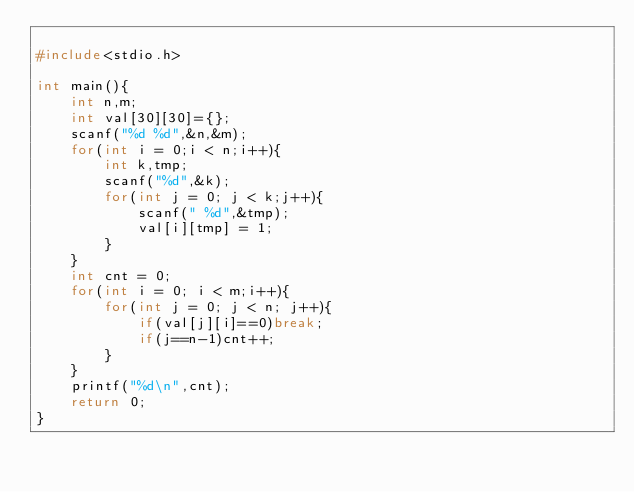<code> <loc_0><loc_0><loc_500><loc_500><_C_>
#include<stdio.h>

int main(){
	int n,m;
	int val[30][30]={};
	scanf("%d %d",&n,&m);
	for(int i = 0;i < n;i++){
		int k,tmp;
		scanf("%d",&k);
		for(int j = 0; j < k;j++){
			scanf(" %d",&tmp);
			val[i][tmp] = 1;
		}
	}
	int cnt = 0;
	for(int i = 0; i < m;i++){
		for(int j = 0; j < n; j++){
			if(val[j][i]==0)break;
			if(j==n-1)cnt++;
		}
	}
	printf("%d\n",cnt);
	return 0;
}


</code> 